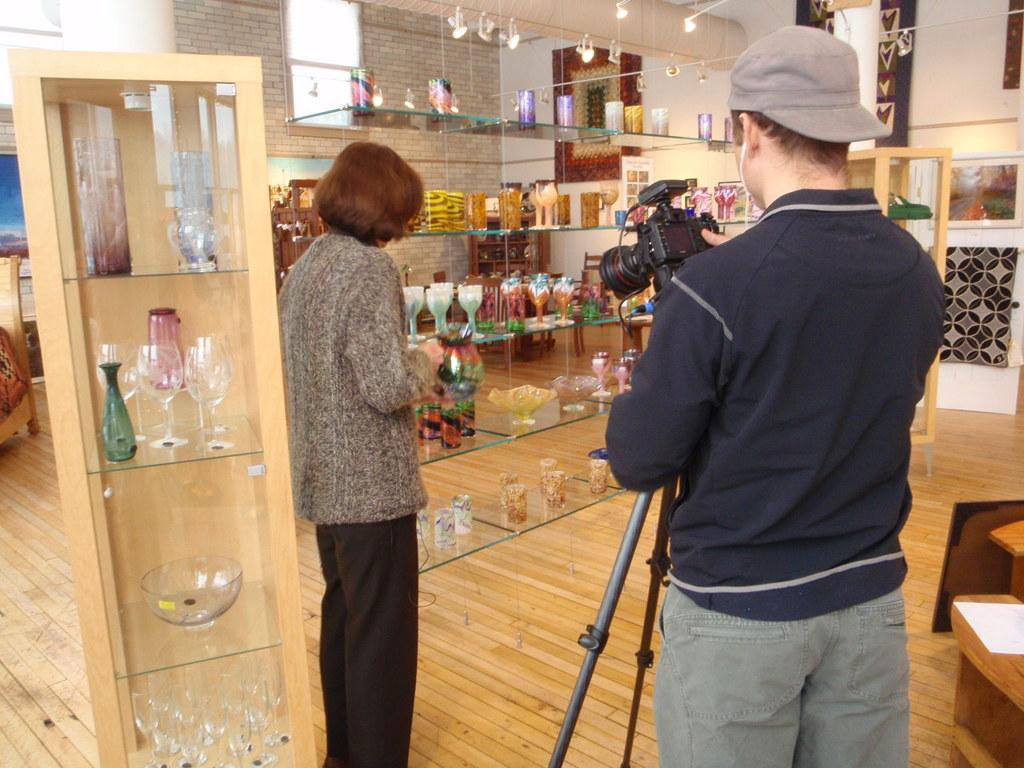Please provide a concise description of this image. In this image I can see two persons are standing in the front and between them I can see a tripod stand and a camera on it. I can also see number of glasses on the racks and on the top side of this image I can see few lights. In the background I can see few frames on the wall. 